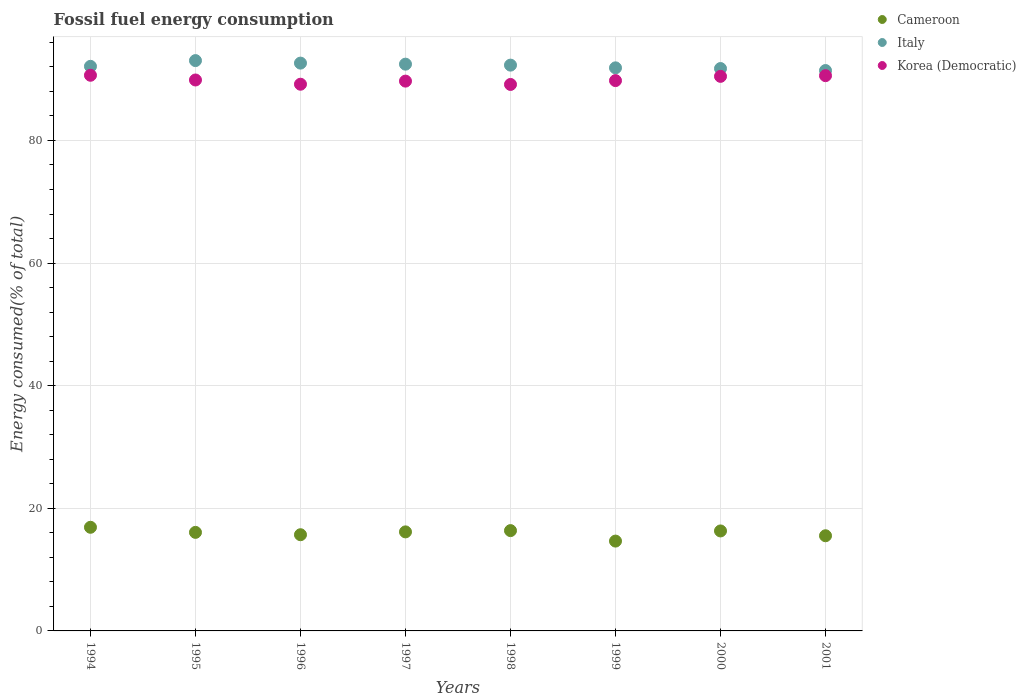How many different coloured dotlines are there?
Provide a short and direct response. 3. What is the percentage of energy consumed in Korea (Democratic) in 2001?
Offer a terse response. 90.57. Across all years, what is the maximum percentage of energy consumed in Korea (Democratic)?
Your answer should be very brief. 90.63. Across all years, what is the minimum percentage of energy consumed in Cameroon?
Provide a succinct answer. 14.65. In which year was the percentage of energy consumed in Cameroon maximum?
Your response must be concise. 1994. What is the total percentage of energy consumed in Korea (Democratic) in the graph?
Give a very brief answer. 719.26. What is the difference between the percentage of energy consumed in Korea (Democratic) in 1997 and that in 2000?
Provide a short and direct response. -0.78. What is the difference between the percentage of energy consumed in Cameroon in 1994 and the percentage of energy consumed in Korea (Democratic) in 1997?
Ensure brevity in your answer.  -72.77. What is the average percentage of energy consumed in Italy per year?
Offer a very short reply. 92.18. In the year 2000, what is the difference between the percentage of energy consumed in Cameroon and percentage of energy consumed in Korea (Democratic)?
Make the answer very short. -74.15. What is the ratio of the percentage of energy consumed in Cameroon in 1999 to that in 2001?
Your answer should be very brief. 0.94. Is the percentage of energy consumed in Korea (Democratic) in 1995 less than that in 2001?
Make the answer very short. Yes. What is the difference between the highest and the second highest percentage of energy consumed in Italy?
Your answer should be compact. 0.41. What is the difference between the highest and the lowest percentage of energy consumed in Korea (Democratic)?
Your answer should be compact. 1.5. In how many years, is the percentage of energy consumed in Cameroon greater than the average percentage of energy consumed in Cameroon taken over all years?
Provide a short and direct response. 5. Is it the case that in every year, the sum of the percentage of energy consumed in Korea (Democratic) and percentage of energy consumed in Cameroon  is greater than the percentage of energy consumed in Italy?
Give a very brief answer. Yes. Is the percentage of energy consumed in Cameroon strictly less than the percentage of energy consumed in Italy over the years?
Provide a short and direct response. Yes. How many dotlines are there?
Ensure brevity in your answer.  3. What is the difference between two consecutive major ticks on the Y-axis?
Provide a succinct answer. 20. Does the graph contain any zero values?
Offer a very short reply. No. How many legend labels are there?
Your response must be concise. 3. How are the legend labels stacked?
Ensure brevity in your answer.  Vertical. What is the title of the graph?
Your answer should be compact. Fossil fuel energy consumption. Does "Andorra" appear as one of the legend labels in the graph?
Give a very brief answer. No. What is the label or title of the Y-axis?
Ensure brevity in your answer.  Energy consumed(% of total). What is the Energy consumed(% of total) in Cameroon in 1994?
Keep it short and to the point. 16.9. What is the Energy consumed(% of total) in Italy in 1994?
Offer a terse response. 92.09. What is the Energy consumed(% of total) of Korea (Democratic) in 1994?
Keep it short and to the point. 90.63. What is the Energy consumed(% of total) of Cameroon in 1995?
Make the answer very short. 16.07. What is the Energy consumed(% of total) of Italy in 1995?
Provide a succinct answer. 93.02. What is the Energy consumed(% of total) of Korea (Democratic) in 1995?
Your answer should be compact. 89.86. What is the Energy consumed(% of total) in Cameroon in 1996?
Your response must be concise. 15.69. What is the Energy consumed(% of total) in Italy in 1996?
Offer a very short reply. 92.61. What is the Energy consumed(% of total) in Korea (Democratic) in 1996?
Ensure brevity in your answer.  89.17. What is the Energy consumed(% of total) in Cameroon in 1997?
Offer a very short reply. 16.15. What is the Energy consumed(% of total) in Italy in 1997?
Provide a succinct answer. 92.44. What is the Energy consumed(% of total) in Korea (Democratic) in 1997?
Offer a terse response. 89.68. What is the Energy consumed(% of total) in Cameroon in 1998?
Make the answer very short. 16.36. What is the Energy consumed(% of total) in Italy in 1998?
Provide a short and direct response. 92.29. What is the Energy consumed(% of total) in Korea (Democratic) in 1998?
Your answer should be compact. 89.13. What is the Energy consumed(% of total) in Cameroon in 1999?
Your response must be concise. 14.65. What is the Energy consumed(% of total) of Italy in 1999?
Your answer should be compact. 91.84. What is the Energy consumed(% of total) in Korea (Democratic) in 1999?
Give a very brief answer. 89.76. What is the Energy consumed(% of total) of Cameroon in 2000?
Your response must be concise. 16.31. What is the Energy consumed(% of total) of Italy in 2000?
Provide a short and direct response. 91.73. What is the Energy consumed(% of total) of Korea (Democratic) in 2000?
Your answer should be compact. 90.45. What is the Energy consumed(% of total) in Cameroon in 2001?
Your response must be concise. 15.52. What is the Energy consumed(% of total) in Italy in 2001?
Offer a terse response. 91.4. What is the Energy consumed(% of total) of Korea (Democratic) in 2001?
Make the answer very short. 90.57. Across all years, what is the maximum Energy consumed(% of total) of Cameroon?
Provide a short and direct response. 16.9. Across all years, what is the maximum Energy consumed(% of total) of Italy?
Your answer should be very brief. 93.02. Across all years, what is the maximum Energy consumed(% of total) in Korea (Democratic)?
Your response must be concise. 90.63. Across all years, what is the minimum Energy consumed(% of total) in Cameroon?
Keep it short and to the point. 14.65. Across all years, what is the minimum Energy consumed(% of total) of Italy?
Your answer should be very brief. 91.4. Across all years, what is the minimum Energy consumed(% of total) in Korea (Democratic)?
Provide a succinct answer. 89.13. What is the total Energy consumed(% of total) in Cameroon in the graph?
Offer a terse response. 127.66. What is the total Energy consumed(% of total) of Italy in the graph?
Your answer should be compact. 737.43. What is the total Energy consumed(% of total) in Korea (Democratic) in the graph?
Ensure brevity in your answer.  719.26. What is the difference between the Energy consumed(% of total) of Cameroon in 1994 and that in 1995?
Give a very brief answer. 0.83. What is the difference between the Energy consumed(% of total) in Italy in 1994 and that in 1995?
Your response must be concise. -0.94. What is the difference between the Energy consumed(% of total) in Korea (Democratic) in 1994 and that in 1995?
Provide a succinct answer. 0.77. What is the difference between the Energy consumed(% of total) of Cameroon in 1994 and that in 1996?
Your response must be concise. 1.22. What is the difference between the Energy consumed(% of total) in Italy in 1994 and that in 1996?
Your answer should be very brief. -0.53. What is the difference between the Energy consumed(% of total) of Korea (Democratic) in 1994 and that in 1996?
Provide a succinct answer. 1.46. What is the difference between the Energy consumed(% of total) in Cameroon in 1994 and that in 1997?
Make the answer very short. 0.75. What is the difference between the Energy consumed(% of total) of Italy in 1994 and that in 1997?
Your answer should be compact. -0.36. What is the difference between the Energy consumed(% of total) of Korea (Democratic) in 1994 and that in 1997?
Ensure brevity in your answer.  0.95. What is the difference between the Energy consumed(% of total) of Cameroon in 1994 and that in 1998?
Provide a short and direct response. 0.54. What is the difference between the Energy consumed(% of total) in Italy in 1994 and that in 1998?
Provide a short and direct response. -0.2. What is the difference between the Energy consumed(% of total) of Korea (Democratic) in 1994 and that in 1998?
Ensure brevity in your answer.  1.5. What is the difference between the Energy consumed(% of total) in Cameroon in 1994 and that in 1999?
Keep it short and to the point. 2.25. What is the difference between the Energy consumed(% of total) of Italy in 1994 and that in 1999?
Provide a succinct answer. 0.25. What is the difference between the Energy consumed(% of total) of Korea (Democratic) in 1994 and that in 1999?
Ensure brevity in your answer.  0.87. What is the difference between the Energy consumed(% of total) of Cameroon in 1994 and that in 2000?
Your answer should be compact. 0.6. What is the difference between the Energy consumed(% of total) of Italy in 1994 and that in 2000?
Your answer should be compact. 0.36. What is the difference between the Energy consumed(% of total) in Korea (Democratic) in 1994 and that in 2000?
Offer a very short reply. 0.18. What is the difference between the Energy consumed(% of total) of Cameroon in 1994 and that in 2001?
Offer a terse response. 1.38. What is the difference between the Energy consumed(% of total) of Italy in 1994 and that in 2001?
Offer a terse response. 0.68. What is the difference between the Energy consumed(% of total) of Korea (Democratic) in 1994 and that in 2001?
Offer a very short reply. 0.07. What is the difference between the Energy consumed(% of total) of Cameroon in 1995 and that in 1996?
Offer a very short reply. 0.38. What is the difference between the Energy consumed(% of total) of Italy in 1995 and that in 1996?
Provide a short and direct response. 0.41. What is the difference between the Energy consumed(% of total) of Korea (Democratic) in 1995 and that in 1996?
Provide a short and direct response. 0.69. What is the difference between the Energy consumed(% of total) of Cameroon in 1995 and that in 1997?
Provide a short and direct response. -0.08. What is the difference between the Energy consumed(% of total) of Italy in 1995 and that in 1997?
Your response must be concise. 0.58. What is the difference between the Energy consumed(% of total) in Korea (Democratic) in 1995 and that in 1997?
Provide a succinct answer. 0.18. What is the difference between the Energy consumed(% of total) in Cameroon in 1995 and that in 1998?
Make the answer very short. -0.29. What is the difference between the Energy consumed(% of total) of Italy in 1995 and that in 1998?
Keep it short and to the point. 0.74. What is the difference between the Energy consumed(% of total) of Korea (Democratic) in 1995 and that in 1998?
Provide a short and direct response. 0.73. What is the difference between the Energy consumed(% of total) of Cameroon in 1995 and that in 1999?
Your response must be concise. 1.42. What is the difference between the Energy consumed(% of total) of Italy in 1995 and that in 1999?
Your response must be concise. 1.18. What is the difference between the Energy consumed(% of total) of Korea (Democratic) in 1995 and that in 1999?
Your answer should be compact. 0.1. What is the difference between the Energy consumed(% of total) of Cameroon in 1995 and that in 2000?
Offer a very short reply. -0.23. What is the difference between the Energy consumed(% of total) of Italy in 1995 and that in 2000?
Provide a succinct answer. 1.3. What is the difference between the Energy consumed(% of total) in Korea (Democratic) in 1995 and that in 2000?
Keep it short and to the point. -0.59. What is the difference between the Energy consumed(% of total) in Cameroon in 1995 and that in 2001?
Keep it short and to the point. 0.55. What is the difference between the Energy consumed(% of total) in Italy in 1995 and that in 2001?
Your response must be concise. 1.62. What is the difference between the Energy consumed(% of total) in Korea (Democratic) in 1995 and that in 2001?
Make the answer very short. -0.7. What is the difference between the Energy consumed(% of total) of Cameroon in 1996 and that in 1997?
Your answer should be compact. -0.46. What is the difference between the Energy consumed(% of total) in Italy in 1996 and that in 1997?
Your answer should be compact. 0.17. What is the difference between the Energy consumed(% of total) in Korea (Democratic) in 1996 and that in 1997?
Keep it short and to the point. -0.51. What is the difference between the Energy consumed(% of total) of Cameroon in 1996 and that in 1998?
Your response must be concise. -0.67. What is the difference between the Energy consumed(% of total) in Italy in 1996 and that in 1998?
Your answer should be compact. 0.33. What is the difference between the Energy consumed(% of total) of Korea (Democratic) in 1996 and that in 1998?
Your answer should be very brief. 0.04. What is the difference between the Energy consumed(% of total) of Cameroon in 1996 and that in 1999?
Your answer should be very brief. 1.04. What is the difference between the Energy consumed(% of total) in Italy in 1996 and that in 1999?
Your response must be concise. 0.77. What is the difference between the Energy consumed(% of total) in Korea (Democratic) in 1996 and that in 1999?
Ensure brevity in your answer.  -0.59. What is the difference between the Energy consumed(% of total) of Cameroon in 1996 and that in 2000?
Your answer should be very brief. -0.62. What is the difference between the Energy consumed(% of total) of Italy in 1996 and that in 2000?
Offer a very short reply. 0.89. What is the difference between the Energy consumed(% of total) in Korea (Democratic) in 1996 and that in 2000?
Make the answer very short. -1.28. What is the difference between the Energy consumed(% of total) of Cameroon in 1996 and that in 2001?
Offer a very short reply. 0.17. What is the difference between the Energy consumed(% of total) of Italy in 1996 and that in 2001?
Ensure brevity in your answer.  1.21. What is the difference between the Energy consumed(% of total) in Korea (Democratic) in 1996 and that in 2001?
Provide a short and direct response. -1.4. What is the difference between the Energy consumed(% of total) in Cameroon in 1997 and that in 1998?
Give a very brief answer. -0.21. What is the difference between the Energy consumed(% of total) of Italy in 1997 and that in 1998?
Provide a short and direct response. 0.16. What is the difference between the Energy consumed(% of total) in Korea (Democratic) in 1997 and that in 1998?
Offer a terse response. 0.54. What is the difference between the Energy consumed(% of total) in Cameroon in 1997 and that in 1999?
Offer a terse response. 1.5. What is the difference between the Energy consumed(% of total) in Italy in 1997 and that in 1999?
Ensure brevity in your answer.  0.6. What is the difference between the Energy consumed(% of total) of Korea (Democratic) in 1997 and that in 1999?
Your answer should be compact. -0.08. What is the difference between the Energy consumed(% of total) in Cameroon in 1997 and that in 2000?
Your response must be concise. -0.15. What is the difference between the Energy consumed(% of total) in Italy in 1997 and that in 2000?
Keep it short and to the point. 0.71. What is the difference between the Energy consumed(% of total) in Korea (Democratic) in 1997 and that in 2000?
Make the answer very short. -0.78. What is the difference between the Energy consumed(% of total) of Cameroon in 1997 and that in 2001?
Your answer should be very brief. 0.63. What is the difference between the Energy consumed(% of total) of Korea (Democratic) in 1997 and that in 2001?
Offer a terse response. -0.89. What is the difference between the Energy consumed(% of total) in Cameroon in 1998 and that in 1999?
Ensure brevity in your answer.  1.71. What is the difference between the Energy consumed(% of total) of Italy in 1998 and that in 1999?
Your answer should be compact. 0.44. What is the difference between the Energy consumed(% of total) in Korea (Democratic) in 1998 and that in 1999?
Your answer should be compact. -0.63. What is the difference between the Energy consumed(% of total) in Cameroon in 1998 and that in 2000?
Keep it short and to the point. 0.05. What is the difference between the Energy consumed(% of total) in Italy in 1998 and that in 2000?
Give a very brief answer. 0.56. What is the difference between the Energy consumed(% of total) in Korea (Democratic) in 1998 and that in 2000?
Your answer should be compact. -1.32. What is the difference between the Energy consumed(% of total) of Cameroon in 1998 and that in 2001?
Offer a terse response. 0.84. What is the difference between the Energy consumed(% of total) of Italy in 1998 and that in 2001?
Your answer should be compact. 0.88. What is the difference between the Energy consumed(% of total) in Korea (Democratic) in 1998 and that in 2001?
Make the answer very short. -1.43. What is the difference between the Energy consumed(% of total) of Cameroon in 1999 and that in 2000?
Offer a terse response. -1.66. What is the difference between the Energy consumed(% of total) in Italy in 1999 and that in 2000?
Make the answer very short. 0.11. What is the difference between the Energy consumed(% of total) of Korea (Democratic) in 1999 and that in 2000?
Make the answer very short. -0.69. What is the difference between the Energy consumed(% of total) of Cameroon in 1999 and that in 2001?
Provide a short and direct response. -0.87. What is the difference between the Energy consumed(% of total) of Italy in 1999 and that in 2001?
Offer a terse response. 0.44. What is the difference between the Energy consumed(% of total) in Korea (Democratic) in 1999 and that in 2001?
Give a very brief answer. -0.81. What is the difference between the Energy consumed(% of total) in Cameroon in 2000 and that in 2001?
Keep it short and to the point. 0.78. What is the difference between the Energy consumed(% of total) in Italy in 2000 and that in 2001?
Make the answer very short. 0.33. What is the difference between the Energy consumed(% of total) of Korea (Democratic) in 2000 and that in 2001?
Make the answer very short. -0.11. What is the difference between the Energy consumed(% of total) in Cameroon in 1994 and the Energy consumed(% of total) in Italy in 1995?
Ensure brevity in your answer.  -76.12. What is the difference between the Energy consumed(% of total) of Cameroon in 1994 and the Energy consumed(% of total) of Korea (Democratic) in 1995?
Make the answer very short. -72.96. What is the difference between the Energy consumed(% of total) of Italy in 1994 and the Energy consumed(% of total) of Korea (Democratic) in 1995?
Keep it short and to the point. 2.23. What is the difference between the Energy consumed(% of total) in Cameroon in 1994 and the Energy consumed(% of total) in Italy in 1996?
Make the answer very short. -75.71. What is the difference between the Energy consumed(% of total) in Cameroon in 1994 and the Energy consumed(% of total) in Korea (Democratic) in 1996?
Your answer should be very brief. -72.27. What is the difference between the Energy consumed(% of total) of Italy in 1994 and the Energy consumed(% of total) of Korea (Democratic) in 1996?
Make the answer very short. 2.92. What is the difference between the Energy consumed(% of total) of Cameroon in 1994 and the Energy consumed(% of total) of Italy in 1997?
Your response must be concise. -75.54. What is the difference between the Energy consumed(% of total) of Cameroon in 1994 and the Energy consumed(% of total) of Korea (Democratic) in 1997?
Your answer should be very brief. -72.77. What is the difference between the Energy consumed(% of total) in Italy in 1994 and the Energy consumed(% of total) in Korea (Democratic) in 1997?
Your answer should be very brief. 2.41. What is the difference between the Energy consumed(% of total) in Cameroon in 1994 and the Energy consumed(% of total) in Italy in 1998?
Your answer should be compact. -75.38. What is the difference between the Energy consumed(% of total) of Cameroon in 1994 and the Energy consumed(% of total) of Korea (Democratic) in 1998?
Your response must be concise. -72.23. What is the difference between the Energy consumed(% of total) in Italy in 1994 and the Energy consumed(% of total) in Korea (Democratic) in 1998?
Keep it short and to the point. 2.95. What is the difference between the Energy consumed(% of total) of Cameroon in 1994 and the Energy consumed(% of total) of Italy in 1999?
Provide a short and direct response. -74.94. What is the difference between the Energy consumed(% of total) of Cameroon in 1994 and the Energy consumed(% of total) of Korea (Democratic) in 1999?
Your answer should be very brief. -72.86. What is the difference between the Energy consumed(% of total) in Italy in 1994 and the Energy consumed(% of total) in Korea (Democratic) in 1999?
Provide a succinct answer. 2.33. What is the difference between the Energy consumed(% of total) of Cameroon in 1994 and the Energy consumed(% of total) of Italy in 2000?
Your answer should be very brief. -74.83. What is the difference between the Energy consumed(% of total) in Cameroon in 1994 and the Energy consumed(% of total) in Korea (Democratic) in 2000?
Keep it short and to the point. -73.55. What is the difference between the Energy consumed(% of total) in Italy in 1994 and the Energy consumed(% of total) in Korea (Democratic) in 2000?
Provide a short and direct response. 1.63. What is the difference between the Energy consumed(% of total) in Cameroon in 1994 and the Energy consumed(% of total) in Italy in 2001?
Provide a short and direct response. -74.5. What is the difference between the Energy consumed(% of total) in Cameroon in 1994 and the Energy consumed(% of total) in Korea (Democratic) in 2001?
Your answer should be very brief. -73.66. What is the difference between the Energy consumed(% of total) in Italy in 1994 and the Energy consumed(% of total) in Korea (Democratic) in 2001?
Keep it short and to the point. 1.52. What is the difference between the Energy consumed(% of total) in Cameroon in 1995 and the Energy consumed(% of total) in Italy in 1996?
Your answer should be compact. -76.54. What is the difference between the Energy consumed(% of total) of Cameroon in 1995 and the Energy consumed(% of total) of Korea (Democratic) in 1996?
Provide a succinct answer. -73.1. What is the difference between the Energy consumed(% of total) of Italy in 1995 and the Energy consumed(% of total) of Korea (Democratic) in 1996?
Your answer should be very brief. 3.85. What is the difference between the Energy consumed(% of total) in Cameroon in 1995 and the Energy consumed(% of total) in Italy in 1997?
Your answer should be very brief. -76.37. What is the difference between the Energy consumed(% of total) of Cameroon in 1995 and the Energy consumed(% of total) of Korea (Democratic) in 1997?
Give a very brief answer. -73.6. What is the difference between the Energy consumed(% of total) of Italy in 1995 and the Energy consumed(% of total) of Korea (Democratic) in 1997?
Keep it short and to the point. 3.35. What is the difference between the Energy consumed(% of total) of Cameroon in 1995 and the Energy consumed(% of total) of Italy in 1998?
Your response must be concise. -76.21. What is the difference between the Energy consumed(% of total) in Cameroon in 1995 and the Energy consumed(% of total) in Korea (Democratic) in 1998?
Offer a terse response. -73.06. What is the difference between the Energy consumed(% of total) of Italy in 1995 and the Energy consumed(% of total) of Korea (Democratic) in 1998?
Offer a terse response. 3.89. What is the difference between the Energy consumed(% of total) of Cameroon in 1995 and the Energy consumed(% of total) of Italy in 1999?
Your response must be concise. -75.77. What is the difference between the Energy consumed(% of total) in Cameroon in 1995 and the Energy consumed(% of total) in Korea (Democratic) in 1999?
Provide a succinct answer. -73.69. What is the difference between the Energy consumed(% of total) of Italy in 1995 and the Energy consumed(% of total) of Korea (Democratic) in 1999?
Offer a terse response. 3.26. What is the difference between the Energy consumed(% of total) of Cameroon in 1995 and the Energy consumed(% of total) of Italy in 2000?
Give a very brief answer. -75.66. What is the difference between the Energy consumed(% of total) of Cameroon in 1995 and the Energy consumed(% of total) of Korea (Democratic) in 2000?
Give a very brief answer. -74.38. What is the difference between the Energy consumed(% of total) in Italy in 1995 and the Energy consumed(% of total) in Korea (Democratic) in 2000?
Give a very brief answer. 2.57. What is the difference between the Energy consumed(% of total) in Cameroon in 1995 and the Energy consumed(% of total) in Italy in 2001?
Keep it short and to the point. -75.33. What is the difference between the Energy consumed(% of total) in Cameroon in 1995 and the Energy consumed(% of total) in Korea (Democratic) in 2001?
Ensure brevity in your answer.  -74.49. What is the difference between the Energy consumed(% of total) in Italy in 1995 and the Energy consumed(% of total) in Korea (Democratic) in 2001?
Ensure brevity in your answer.  2.46. What is the difference between the Energy consumed(% of total) in Cameroon in 1996 and the Energy consumed(% of total) in Italy in 1997?
Provide a short and direct response. -76.75. What is the difference between the Energy consumed(% of total) of Cameroon in 1996 and the Energy consumed(% of total) of Korea (Democratic) in 1997?
Give a very brief answer. -73.99. What is the difference between the Energy consumed(% of total) in Italy in 1996 and the Energy consumed(% of total) in Korea (Democratic) in 1997?
Give a very brief answer. 2.94. What is the difference between the Energy consumed(% of total) in Cameroon in 1996 and the Energy consumed(% of total) in Italy in 1998?
Offer a terse response. -76.6. What is the difference between the Energy consumed(% of total) of Cameroon in 1996 and the Energy consumed(% of total) of Korea (Democratic) in 1998?
Give a very brief answer. -73.44. What is the difference between the Energy consumed(% of total) of Italy in 1996 and the Energy consumed(% of total) of Korea (Democratic) in 1998?
Your answer should be compact. 3.48. What is the difference between the Energy consumed(% of total) of Cameroon in 1996 and the Energy consumed(% of total) of Italy in 1999?
Keep it short and to the point. -76.15. What is the difference between the Energy consumed(% of total) in Cameroon in 1996 and the Energy consumed(% of total) in Korea (Democratic) in 1999?
Provide a succinct answer. -74.07. What is the difference between the Energy consumed(% of total) of Italy in 1996 and the Energy consumed(% of total) of Korea (Democratic) in 1999?
Ensure brevity in your answer.  2.85. What is the difference between the Energy consumed(% of total) in Cameroon in 1996 and the Energy consumed(% of total) in Italy in 2000?
Your answer should be very brief. -76.04. What is the difference between the Energy consumed(% of total) in Cameroon in 1996 and the Energy consumed(% of total) in Korea (Democratic) in 2000?
Keep it short and to the point. -74.77. What is the difference between the Energy consumed(% of total) of Italy in 1996 and the Energy consumed(% of total) of Korea (Democratic) in 2000?
Keep it short and to the point. 2.16. What is the difference between the Energy consumed(% of total) in Cameroon in 1996 and the Energy consumed(% of total) in Italy in 2001?
Your answer should be compact. -75.71. What is the difference between the Energy consumed(% of total) of Cameroon in 1996 and the Energy consumed(% of total) of Korea (Democratic) in 2001?
Make the answer very short. -74.88. What is the difference between the Energy consumed(% of total) in Italy in 1996 and the Energy consumed(% of total) in Korea (Democratic) in 2001?
Provide a short and direct response. 2.05. What is the difference between the Energy consumed(% of total) of Cameroon in 1997 and the Energy consumed(% of total) of Italy in 1998?
Offer a very short reply. -76.13. What is the difference between the Energy consumed(% of total) of Cameroon in 1997 and the Energy consumed(% of total) of Korea (Democratic) in 1998?
Offer a very short reply. -72.98. What is the difference between the Energy consumed(% of total) of Italy in 1997 and the Energy consumed(% of total) of Korea (Democratic) in 1998?
Your answer should be compact. 3.31. What is the difference between the Energy consumed(% of total) in Cameroon in 1997 and the Energy consumed(% of total) in Italy in 1999?
Provide a succinct answer. -75.69. What is the difference between the Energy consumed(% of total) in Cameroon in 1997 and the Energy consumed(% of total) in Korea (Democratic) in 1999?
Keep it short and to the point. -73.61. What is the difference between the Energy consumed(% of total) of Italy in 1997 and the Energy consumed(% of total) of Korea (Democratic) in 1999?
Offer a very short reply. 2.68. What is the difference between the Energy consumed(% of total) of Cameroon in 1997 and the Energy consumed(% of total) of Italy in 2000?
Make the answer very short. -75.58. What is the difference between the Energy consumed(% of total) in Cameroon in 1997 and the Energy consumed(% of total) in Korea (Democratic) in 2000?
Provide a short and direct response. -74.3. What is the difference between the Energy consumed(% of total) in Italy in 1997 and the Energy consumed(% of total) in Korea (Democratic) in 2000?
Provide a short and direct response. 1.99. What is the difference between the Energy consumed(% of total) of Cameroon in 1997 and the Energy consumed(% of total) of Italy in 2001?
Keep it short and to the point. -75.25. What is the difference between the Energy consumed(% of total) in Cameroon in 1997 and the Energy consumed(% of total) in Korea (Democratic) in 2001?
Keep it short and to the point. -74.41. What is the difference between the Energy consumed(% of total) of Italy in 1997 and the Energy consumed(% of total) of Korea (Democratic) in 2001?
Provide a short and direct response. 1.88. What is the difference between the Energy consumed(% of total) in Cameroon in 1998 and the Energy consumed(% of total) in Italy in 1999?
Give a very brief answer. -75.48. What is the difference between the Energy consumed(% of total) of Cameroon in 1998 and the Energy consumed(% of total) of Korea (Democratic) in 1999?
Your answer should be compact. -73.4. What is the difference between the Energy consumed(% of total) in Italy in 1998 and the Energy consumed(% of total) in Korea (Democratic) in 1999?
Ensure brevity in your answer.  2.52. What is the difference between the Energy consumed(% of total) of Cameroon in 1998 and the Energy consumed(% of total) of Italy in 2000?
Keep it short and to the point. -75.37. What is the difference between the Energy consumed(% of total) in Cameroon in 1998 and the Energy consumed(% of total) in Korea (Democratic) in 2000?
Your answer should be very brief. -74.09. What is the difference between the Energy consumed(% of total) of Italy in 1998 and the Energy consumed(% of total) of Korea (Democratic) in 2000?
Give a very brief answer. 1.83. What is the difference between the Energy consumed(% of total) of Cameroon in 1998 and the Energy consumed(% of total) of Italy in 2001?
Make the answer very short. -75.04. What is the difference between the Energy consumed(% of total) of Cameroon in 1998 and the Energy consumed(% of total) of Korea (Democratic) in 2001?
Offer a terse response. -74.21. What is the difference between the Energy consumed(% of total) in Italy in 1998 and the Energy consumed(% of total) in Korea (Democratic) in 2001?
Make the answer very short. 1.72. What is the difference between the Energy consumed(% of total) in Cameroon in 1999 and the Energy consumed(% of total) in Italy in 2000?
Ensure brevity in your answer.  -77.08. What is the difference between the Energy consumed(% of total) of Cameroon in 1999 and the Energy consumed(% of total) of Korea (Democratic) in 2000?
Keep it short and to the point. -75.8. What is the difference between the Energy consumed(% of total) in Italy in 1999 and the Energy consumed(% of total) in Korea (Democratic) in 2000?
Your answer should be compact. 1.39. What is the difference between the Energy consumed(% of total) in Cameroon in 1999 and the Energy consumed(% of total) in Italy in 2001?
Your answer should be compact. -76.75. What is the difference between the Energy consumed(% of total) of Cameroon in 1999 and the Energy consumed(% of total) of Korea (Democratic) in 2001?
Keep it short and to the point. -75.92. What is the difference between the Energy consumed(% of total) of Italy in 1999 and the Energy consumed(% of total) of Korea (Democratic) in 2001?
Your response must be concise. 1.27. What is the difference between the Energy consumed(% of total) in Cameroon in 2000 and the Energy consumed(% of total) in Italy in 2001?
Give a very brief answer. -75.1. What is the difference between the Energy consumed(% of total) in Cameroon in 2000 and the Energy consumed(% of total) in Korea (Democratic) in 2001?
Give a very brief answer. -74.26. What is the difference between the Energy consumed(% of total) in Italy in 2000 and the Energy consumed(% of total) in Korea (Democratic) in 2001?
Your answer should be very brief. 1.16. What is the average Energy consumed(% of total) of Cameroon per year?
Offer a very short reply. 15.96. What is the average Energy consumed(% of total) of Italy per year?
Offer a very short reply. 92.18. What is the average Energy consumed(% of total) in Korea (Democratic) per year?
Keep it short and to the point. 89.91. In the year 1994, what is the difference between the Energy consumed(% of total) of Cameroon and Energy consumed(% of total) of Italy?
Make the answer very short. -75.18. In the year 1994, what is the difference between the Energy consumed(% of total) in Cameroon and Energy consumed(% of total) in Korea (Democratic)?
Offer a terse response. -73.73. In the year 1994, what is the difference between the Energy consumed(% of total) of Italy and Energy consumed(% of total) of Korea (Democratic)?
Make the answer very short. 1.46. In the year 1995, what is the difference between the Energy consumed(% of total) in Cameroon and Energy consumed(% of total) in Italy?
Make the answer very short. -76.95. In the year 1995, what is the difference between the Energy consumed(% of total) of Cameroon and Energy consumed(% of total) of Korea (Democratic)?
Give a very brief answer. -73.79. In the year 1995, what is the difference between the Energy consumed(% of total) of Italy and Energy consumed(% of total) of Korea (Democratic)?
Offer a terse response. 3.16. In the year 1996, what is the difference between the Energy consumed(% of total) in Cameroon and Energy consumed(% of total) in Italy?
Make the answer very short. -76.93. In the year 1996, what is the difference between the Energy consumed(% of total) in Cameroon and Energy consumed(% of total) in Korea (Democratic)?
Keep it short and to the point. -73.48. In the year 1996, what is the difference between the Energy consumed(% of total) in Italy and Energy consumed(% of total) in Korea (Democratic)?
Ensure brevity in your answer.  3.44. In the year 1997, what is the difference between the Energy consumed(% of total) of Cameroon and Energy consumed(% of total) of Italy?
Provide a short and direct response. -76.29. In the year 1997, what is the difference between the Energy consumed(% of total) of Cameroon and Energy consumed(% of total) of Korea (Democratic)?
Your answer should be compact. -73.52. In the year 1997, what is the difference between the Energy consumed(% of total) of Italy and Energy consumed(% of total) of Korea (Democratic)?
Your answer should be very brief. 2.76. In the year 1998, what is the difference between the Energy consumed(% of total) in Cameroon and Energy consumed(% of total) in Italy?
Provide a succinct answer. -75.93. In the year 1998, what is the difference between the Energy consumed(% of total) in Cameroon and Energy consumed(% of total) in Korea (Democratic)?
Offer a very short reply. -72.77. In the year 1998, what is the difference between the Energy consumed(% of total) of Italy and Energy consumed(% of total) of Korea (Democratic)?
Offer a terse response. 3.15. In the year 1999, what is the difference between the Energy consumed(% of total) of Cameroon and Energy consumed(% of total) of Italy?
Give a very brief answer. -77.19. In the year 1999, what is the difference between the Energy consumed(% of total) of Cameroon and Energy consumed(% of total) of Korea (Democratic)?
Provide a succinct answer. -75.11. In the year 1999, what is the difference between the Energy consumed(% of total) in Italy and Energy consumed(% of total) in Korea (Democratic)?
Your response must be concise. 2.08. In the year 2000, what is the difference between the Energy consumed(% of total) of Cameroon and Energy consumed(% of total) of Italy?
Your answer should be very brief. -75.42. In the year 2000, what is the difference between the Energy consumed(% of total) of Cameroon and Energy consumed(% of total) of Korea (Democratic)?
Offer a very short reply. -74.15. In the year 2000, what is the difference between the Energy consumed(% of total) in Italy and Energy consumed(% of total) in Korea (Democratic)?
Ensure brevity in your answer.  1.27. In the year 2001, what is the difference between the Energy consumed(% of total) in Cameroon and Energy consumed(% of total) in Italy?
Ensure brevity in your answer.  -75.88. In the year 2001, what is the difference between the Energy consumed(% of total) in Cameroon and Energy consumed(% of total) in Korea (Democratic)?
Provide a succinct answer. -75.04. In the year 2001, what is the difference between the Energy consumed(% of total) of Italy and Energy consumed(% of total) of Korea (Democratic)?
Your response must be concise. 0.84. What is the ratio of the Energy consumed(% of total) of Cameroon in 1994 to that in 1995?
Provide a succinct answer. 1.05. What is the ratio of the Energy consumed(% of total) in Korea (Democratic) in 1994 to that in 1995?
Offer a very short reply. 1.01. What is the ratio of the Energy consumed(% of total) in Cameroon in 1994 to that in 1996?
Provide a short and direct response. 1.08. What is the ratio of the Energy consumed(% of total) of Italy in 1994 to that in 1996?
Keep it short and to the point. 0.99. What is the ratio of the Energy consumed(% of total) in Korea (Democratic) in 1994 to that in 1996?
Make the answer very short. 1.02. What is the ratio of the Energy consumed(% of total) in Cameroon in 1994 to that in 1997?
Offer a very short reply. 1.05. What is the ratio of the Energy consumed(% of total) of Italy in 1994 to that in 1997?
Provide a short and direct response. 1. What is the ratio of the Energy consumed(% of total) in Korea (Democratic) in 1994 to that in 1997?
Keep it short and to the point. 1.01. What is the ratio of the Energy consumed(% of total) in Italy in 1994 to that in 1998?
Give a very brief answer. 1. What is the ratio of the Energy consumed(% of total) of Korea (Democratic) in 1994 to that in 1998?
Offer a very short reply. 1.02. What is the ratio of the Energy consumed(% of total) of Cameroon in 1994 to that in 1999?
Give a very brief answer. 1.15. What is the ratio of the Energy consumed(% of total) in Korea (Democratic) in 1994 to that in 1999?
Give a very brief answer. 1.01. What is the ratio of the Energy consumed(% of total) of Cameroon in 1994 to that in 2000?
Ensure brevity in your answer.  1.04. What is the ratio of the Energy consumed(% of total) of Korea (Democratic) in 1994 to that in 2000?
Ensure brevity in your answer.  1. What is the ratio of the Energy consumed(% of total) of Cameroon in 1994 to that in 2001?
Ensure brevity in your answer.  1.09. What is the ratio of the Energy consumed(% of total) in Italy in 1994 to that in 2001?
Offer a terse response. 1.01. What is the ratio of the Energy consumed(% of total) in Cameroon in 1995 to that in 1996?
Give a very brief answer. 1.02. What is the ratio of the Energy consumed(% of total) in Italy in 1995 to that in 1996?
Make the answer very short. 1. What is the ratio of the Energy consumed(% of total) in Korea (Democratic) in 1995 to that in 1996?
Offer a terse response. 1.01. What is the ratio of the Energy consumed(% of total) in Cameroon in 1995 to that in 1998?
Provide a succinct answer. 0.98. What is the ratio of the Energy consumed(% of total) of Italy in 1995 to that in 1998?
Your answer should be very brief. 1.01. What is the ratio of the Energy consumed(% of total) in Korea (Democratic) in 1995 to that in 1998?
Give a very brief answer. 1.01. What is the ratio of the Energy consumed(% of total) in Cameroon in 1995 to that in 1999?
Provide a short and direct response. 1.1. What is the ratio of the Energy consumed(% of total) of Italy in 1995 to that in 1999?
Ensure brevity in your answer.  1.01. What is the ratio of the Energy consumed(% of total) of Cameroon in 1995 to that in 2000?
Your answer should be compact. 0.99. What is the ratio of the Energy consumed(% of total) in Italy in 1995 to that in 2000?
Your answer should be very brief. 1.01. What is the ratio of the Energy consumed(% of total) of Korea (Democratic) in 1995 to that in 2000?
Provide a succinct answer. 0.99. What is the ratio of the Energy consumed(% of total) of Cameroon in 1995 to that in 2001?
Make the answer very short. 1.04. What is the ratio of the Energy consumed(% of total) in Italy in 1995 to that in 2001?
Give a very brief answer. 1.02. What is the ratio of the Energy consumed(% of total) in Korea (Democratic) in 1995 to that in 2001?
Give a very brief answer. 0.99. What is the ratio of the Energy consumed(% of total) of Cameroon in 1996 to that in 1997?
Provide a short and direct response. 0.97. What is the ratio of the Energy consumed(% of total) in Italy in 1996 to that in 1997?
Offer a terse response. 1. What is the ratio of the Energy consumed(% of total) in Italy in 1996 to that in 1998?
Your answer should be compact. 1. What is the ratio of the Energy consumed(% of total) of Cameroon in 1996 to that in 1999?
Ensure brevity in your answer.  1.07. What is the ratio of the Energy consumed(% of total) in Italy in 1996 to that in 1999?
Make the answer very short. 1.01. What is the ratio of the Energy consumed(% of total) of Korea (Democratic) in 1996 to that in 1999?
Offer a very short reply. 0.99. What is the ratio of the Energy consumed(% of total) of Cameroon in 1996 to that in 2000?
Your response must be concise. 0.96. What is the ratio of the Energy consumed(% of total) in Italy in 1996 to that in 2000?
Provide a short and direct response. 1.01. What is the ratio of the Energy consumed(% of total) in Korea (Democratic) in 1996 to that in 2000?
Your answer should be compact. 0.99. What is the ratio of the Energy consumed(% of total) in Cameroon in 1996 to that in 2001?
Give a very brief answer. 1.01. What is the ratio of the Energy consumed(% of total) in Italy in 1996 to that in 2001?
Offer a very short reply. 1.01. What is the ratio of the Energy consumed(% of total) in Korea (Democratic) in 1996 to that in 2001?
Offer a terse response. 0.98. What is the ratio of the Energy consumed(% of total) of Cameroon in 1997 to that in 1998?
Provide a succinct answer. 0.99. What is the ratio of the Energy consumed(% of total) of Italy in 1997 to that in 1998?
Make the answer very short. 1. What is the ratio of the Energy consumed(% of total) in Korea (Democratic) in 1997 to that in 1998?
Provide a succinct answer. 1.01. What is the ratio of the Energy consumed(% of total) of Cameroon in 1997 to that in 1999?
Offer a terse response. 1.1. What is the ratio of the Energy consumed(% of total) of Italy in 1997 to that in 1999?
Your answer should be very brief. 1.01. What is the ratio of the Energy consumed(% of total) in Korea (Democratic) in 1997 to that in 1999?
Ensure brevity in your answer.  1. What is the ratio of the Energy consumed(% of total) in Cameroon in 1997 to that in 2000?
Offer a very short reply. 0.99. What is the ratio of the Energy consumed(% of total) of Cameroon in 1997 to that in 2001?
Keep it short and to the point. 1.04. What is the ratio of the Energy consumed(% of total) in Italy in 1997 to that in 2001?
Give a very brief answer. 1.01. What is the ratio of the Energy consumed(% of total) of Korea (Democratic) in 1997 to that in 2001?
Your answer should be very brief. 0.99. What is the ratio of the Energy consumed(% of total) of Cameroon in 1998 to that in 1999?
Provide a short and direct response. 1.12. What is the ratio of the Energy consumed(% of total) in Korea (Democratic) in 1998 to that in 1999?
Keep it short and to the point. 0.99. What is the ratio of the Energy consumed(% of total) in Cameroon in 1998 to that in 2000?
Offer a very short reply. 1. What is the ratio of the Energy consumed(% of total) of Korea (Democratic) in 1998 to that in 2000?
Give a very brief answer. 0.99. What is the ratio of the Energy consumed(% of total) in Cameroon in 1998 to that in 2001?
Your answer should be compact. 1.05. What is the ratio of the Energy consumed(% of total) in Italy in 1998 to that in 2001?
Ensure brevity in your answer.  1.01. What is the ratio of the Energy consumed(% of total) of Korea (Democratic) in 1998 to that in 2001?
Offer a terse response. 0.98. What is the ratio of the Energy consumed(% of total) in Cameroon in 1999 to that in 2000?
Your answer should be compact. 0.9. What is the ratio of the Energy consumed(% of total) of Italy in 1999 to that in 2000?
Offer a terse response. 1. What is the ratio of the Energy consumed(% of total) in Korea (Democratic) in 1999 to that in 2000?
Your answer should be very brief. 0.99. What is the ratio of the Energy consumed(% of total) of Cameroon in 1999 to that in 2001?
Offer a terse response. 0.94. What is the ratio of the Energy consumed(% of total) in Italy in 1999 to that in 2001?
Provide a short and direct response. 1. What is the ratio of the Energy consumed(% of total) of Korea (Democratic) in 1999 to that in 2001?
Keep it short and to the point. 0.99. What is the ratio of the Energy consumed(% of total) in Cameroon in 2000 to that in 2001?
Offer a very short reply. 1.05. What is the ratio of the Energy consumed(% of total) of Italy in 2000 to that in 2001?
Provide a succinct answer. 1. What is the ratio of the Energy consumed(% of total) of Korea (Democratic) in 2000 to that in 2001?
Give a very brief answer. 1. What is the difference between the highest and the second highest Energy consumed(% of total) in Cameroon?
Your answer should be compact. 0.54. What is the difference between the highest and the second highest Energy consumed(% of total) of Italy?
Keep it short and to the point. 0.41. What is the difference between the highest and the second highest Energy consumed(% of total) of Korea (Democratic)?
Your answer should be compact. 0.07. What is the difference between the highest and the lowest Energy consumed(% of total) of Cameroon?
Give a very brief answer. 2.25. What is the difference between the highest and the lowest Energy consumed(% of total) in Italy?
Provide a succinct answer. 1.62. What is the difference between the highest and the lowest Energy consumed(% of total) of Korea (Democratic)?
Provide a succinct answer. 1.5. 